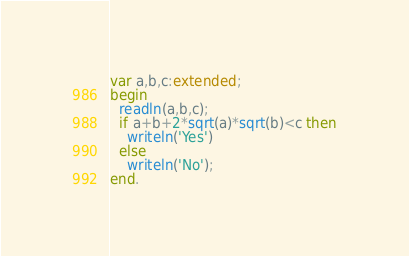Convert code to text. <code><loc_0><loc_0><loc_500><loc_500><_Pascal_>var a,b,c:extended;
begin
  readln(a,b,c);
  if a+b+2*sqrt(a)*sqrt(b)<c then
    writeln('Yes')
  else
    writeln('No');
end.</code> 